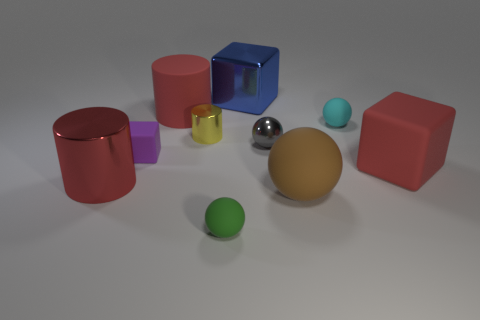What is the size of the green rubber sphere?
Make the answer very short. Small. What is the color of the large cylinder that is made of the same material as the blue cube?
Your answer should be compact. Red. What number of green blocks are made of the same material as the brown object?
Make the answer very short. 0. Is the color of the big shiny cylinder the same as the large cylinder that is on the right side of the red shiny cylinder?
Offer a very short reply. Yes. There is a tiny matte thing to the right of the brown matte ball in front of the red rubber cube; what color is it?
Keep it short and to the point. Cyan. There is a matte block that is the same size as the yellow cylinder; what color is it?
Offer a very short reply. Purple. Is there a tiny cyan object that has the same shape as the brown thing?
Offer a terse response. Yes. What shape is the big blue object?
Your answer should be very brief. Cube. Is the number of yellow shiny cylinders that are in front of the red cube greater than the number of big red shiny cylinders behind the large rubber cylinder?
Your response must be concise. No. How many other objects are there of the same size as the purple cube?
Offer a very short reply. 4. 